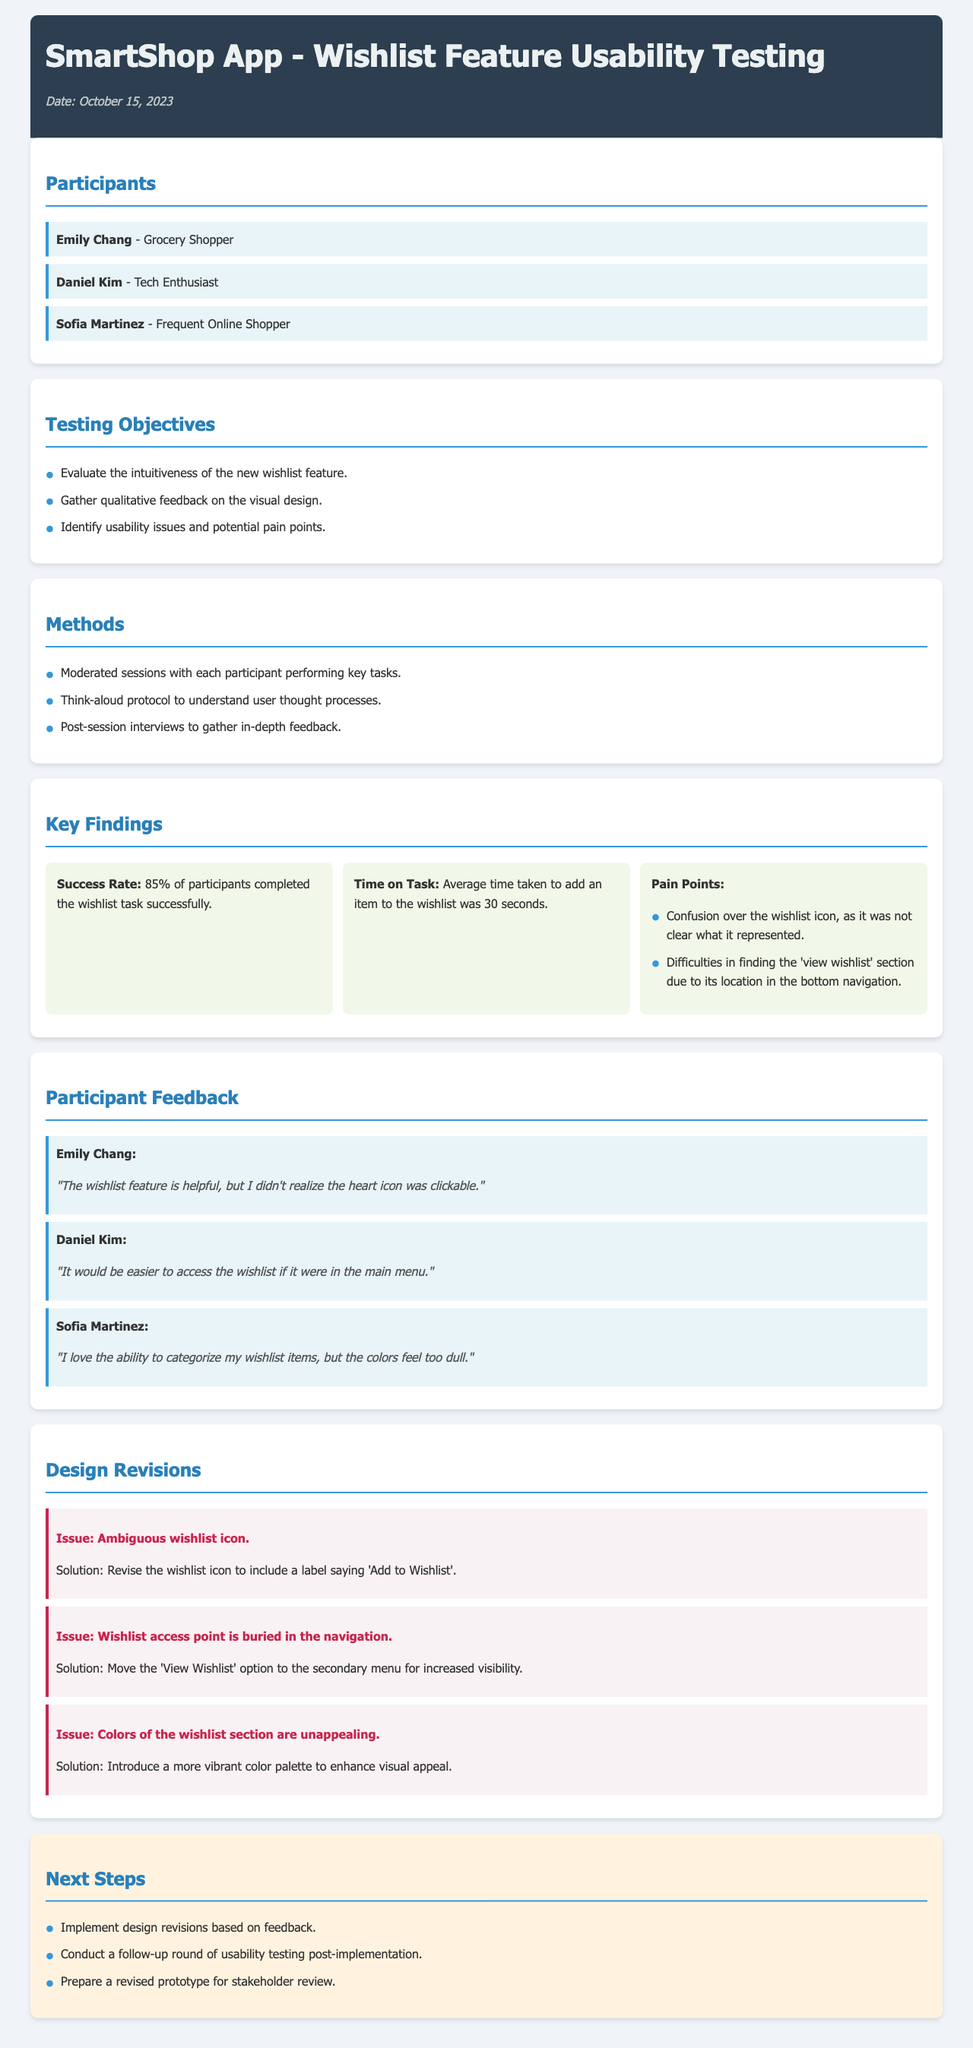What is the date of the report? The date is indicated in the header of the document.
Answer: October 15, 2023 Who is the first participant listed? The participants are listed in a dedicated section, the first one is mentioned.
Answer: Emily Chang What was the average time taken to add an item to the wishlist? The document provides a specific metric in the key findings section.
Answer: 30 seconds What issue was identified regarding the wishlist icon? The document outlines specific issues in the design revisions section.
Answer: Ambiguous wishlist icon How many participants completed the wishlist task successfully? Success rate data is included in the key findings section.
Answer: 85% What is one of the pain points mentioned by participants? The pain points are listed under key findings and include specific user feedback.
Answer: Confusion over the wishlist icon What solution was proposed for the wishlist access issue? The solutions are provided in the design revisions section for identified issues.
Answer: Move the 'View Wishlist' option to the secondary menu Which participant suggested that the wishlist colors are dull? Feedback from participants is summarized in a section dedicated to their comments.
Answer: Sofia Martinez What is one of the next steps mentioned in the document? Next steps are outlined at the end of the report summarizing the actions to be taken.
Answer: Implement design revisions based on feedback 